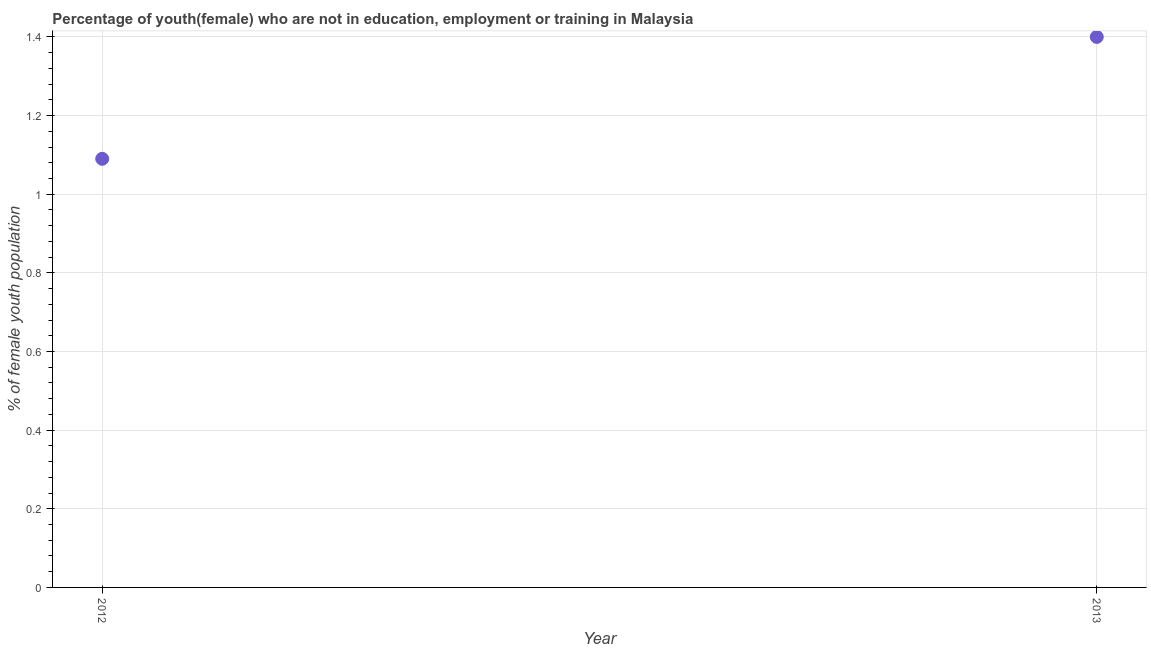What is the unemployed female youth population in 2012?
Your answer should be compact. 1.09. Across all years, what is the maximum unemployed female youth population?
Offer a terse response. 1.4. Across all years, what is the minimum unemployed female youth population?
Give a very brief answer. 1.09. In which year was the unemployed female youth population maximum?
Offer a terse response. 2013. In which year was the unemployed female youth population minimum?
Ensure brevity in your answer.  2012. What is the sum of the unemployed female youth population?
Provide a succinct answer. 2.49. What is the difference between the unemployed female youth population in 2012 and 2013?
Your response must be concise. -0.31. What is the average unemployed female youth population per year?
Make the answer very short. 1.25. What is the median unemployed female youth population?
Ensure brevity in your answer.  1.25. What is the ratio of the unemployed female youth population in 2012 to that in 2013?
Provide a short and direct response. 0.78. How many years are there in the graph?
Your answer should be very brief. 2. Does the graph contain grids?
Offer a very short reply. Yes. What is the title of the graph?
Ensure brevity in your answer.  Percentage of youth(female) who are not in education, employment or training in Malaysia. What is the label or title of the X-axis?
Ensure brevity in your answer.  Year. What is the label or title of the Y-axis?
Give a very brief answer. % of female youth population. What is the % of female youth population in 2012?
Give a very brief answer. 1.09. What is the % of female youth population in 2013?
Offer a very short reply. 1.4. What is the difference between the % of female youth population in 2012 and 2013?
Make the answer very short. -0.31. What is the ratio of the % of female youth population in 2012 to that in 2013?
Make the answer very short. 0.78. 